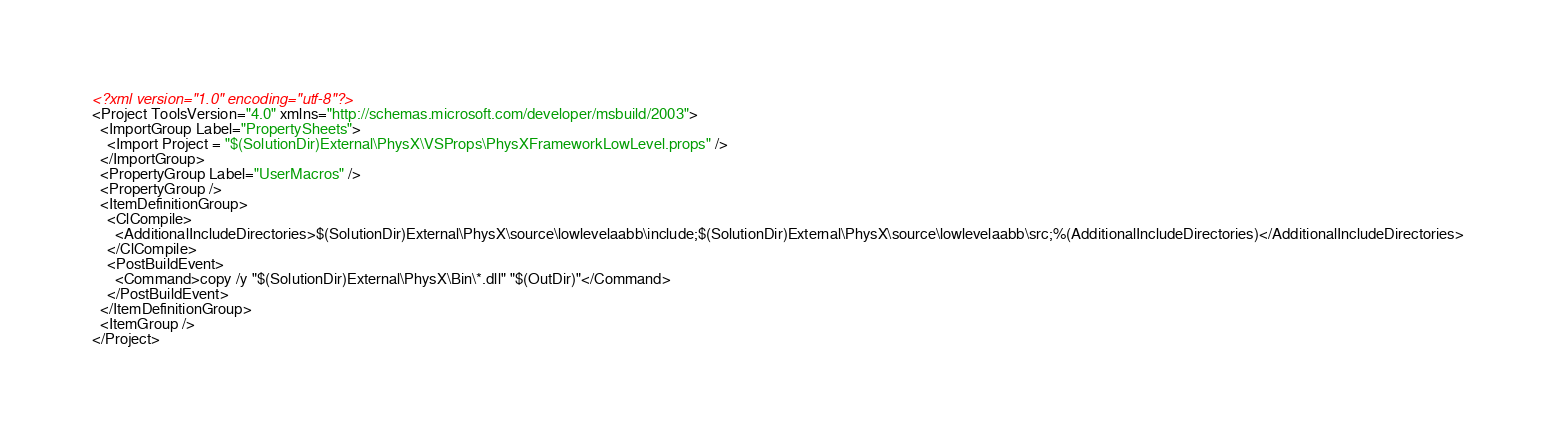Convert code to text. <code><loc_0><loc_0><loc_500><loc_500><_XML_><?xml version="1.0" encoding="utf-8"?>
<Project ToolsVersion="4.0" xmlns="http://schemas.microsoft.com/developer/msbuild/2003">
  <ImportGroup Label="PropertySheets">
    <Import Project = "$(SolutionDir)External\PhysX\VSProps\PhysXFrameworkLowLevel.props" />
  </ImportGroup>
  <PropertyGroup Label="UserMacros" />
  <PropertyGroup />
  <ItemDefinitionGroup>
    <ClCompile>
      <AdditionalIncludeDirectories>$(SolutionDir)External\PhysX\source\lowlevelaabb\include;$(SolutionDir)External\PhysX\source\lowlevelaabb\src;%(AdditionalIncludeDirectories)</AdditionalIncludeDirectories>
    </ClCompile>
    <PostBuildEvent>
      <Command>copy /y "$(SolutionDir)External\PhysX\Bin\*.dll" "$(OutDir)"</Command>
    </PostBuildEvent>
  </ItemDefinitionGroup>
  <ItemGroup />
</Project></code> 